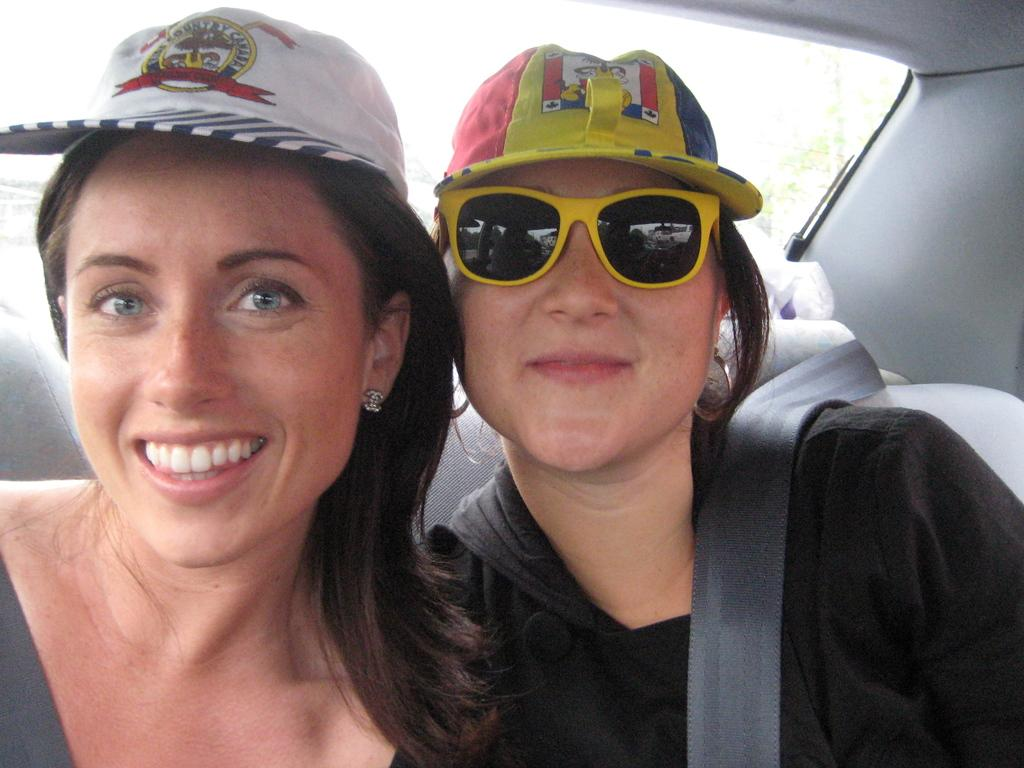How many girls are in the image? There are two girls in the image. Where are the girls located in the image? The girls are in the center of the image. What are the girls doing in the image? The girls are in a car. What are the girls wearing on their heads? The girls are wearing caps. Can you tell me how many wrens are sitting on the cabbage in the image? There are no wrens or cabbage present in the image. What statement is being made by the girls in the image? The image does not provide any information about a statement being made by the girls. 